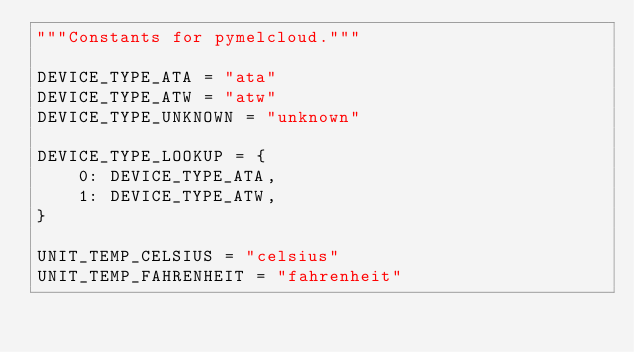Convert code to text. <code><loc_0><loc_0><loc_500><loc_500><_Python_>"""Constants for pymelcloud."""

DEVICE_TYPE_ATA = "ata"
DEVICE_TYPE_ATW = "atw"
DEVICE_TYPE_UNKNOWN = "unknown"

DEVICE_TYPE_LOOKUP = {
    0: DEVICE_TYPE_ATA,
    1: DEVICE_TYPE_ATW,
}

UNIT_TEMP_CELSIUS = "celsius"
UNIT_TEMP_FAHRENHEIT = "fahrenheit"
</code> 